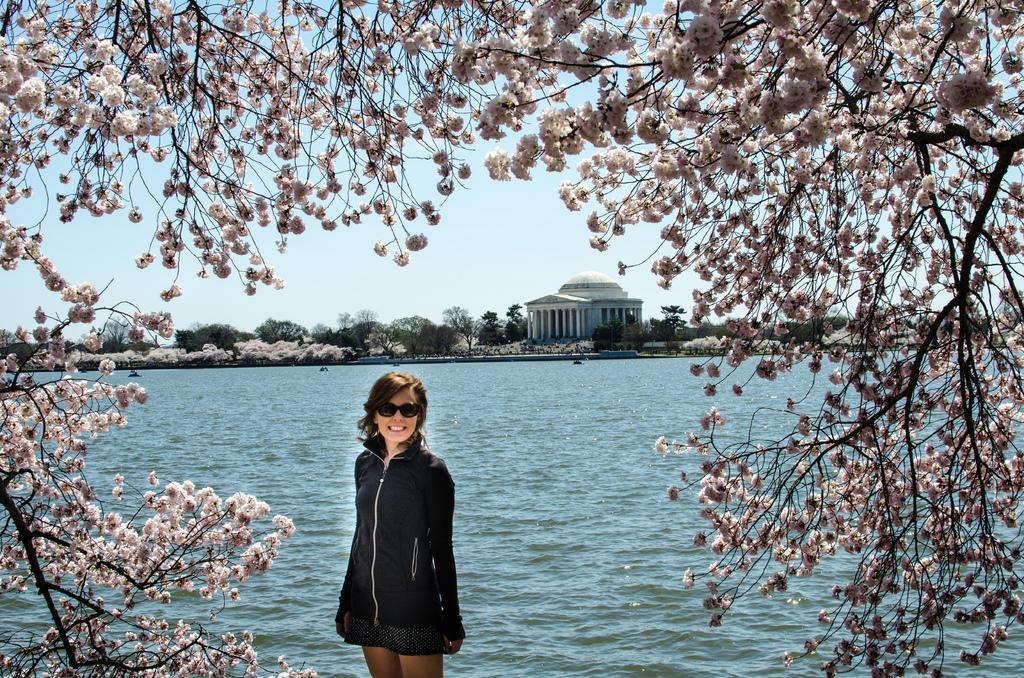Describe this image in one or two sentences. In this image we can see blossom and a woman standing. In the background there are buildings, trees, water and sky. 